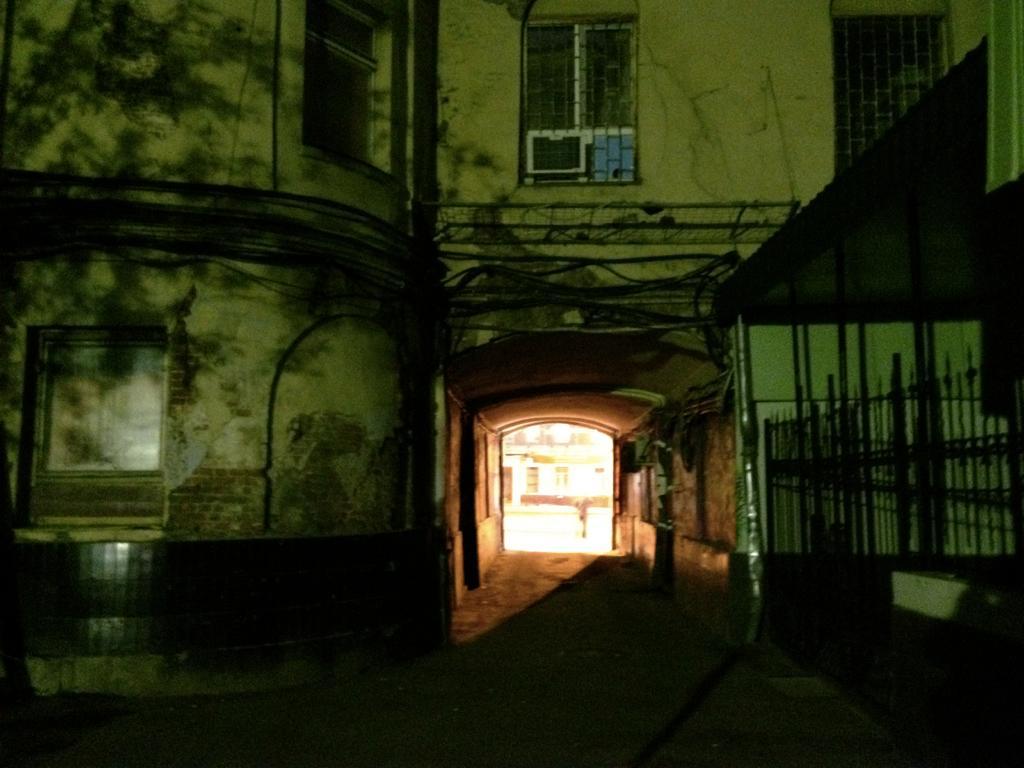Describe this image in one or two sentences. In this picture I can see a building with windows, there are iron grilles and an air conditioner. 